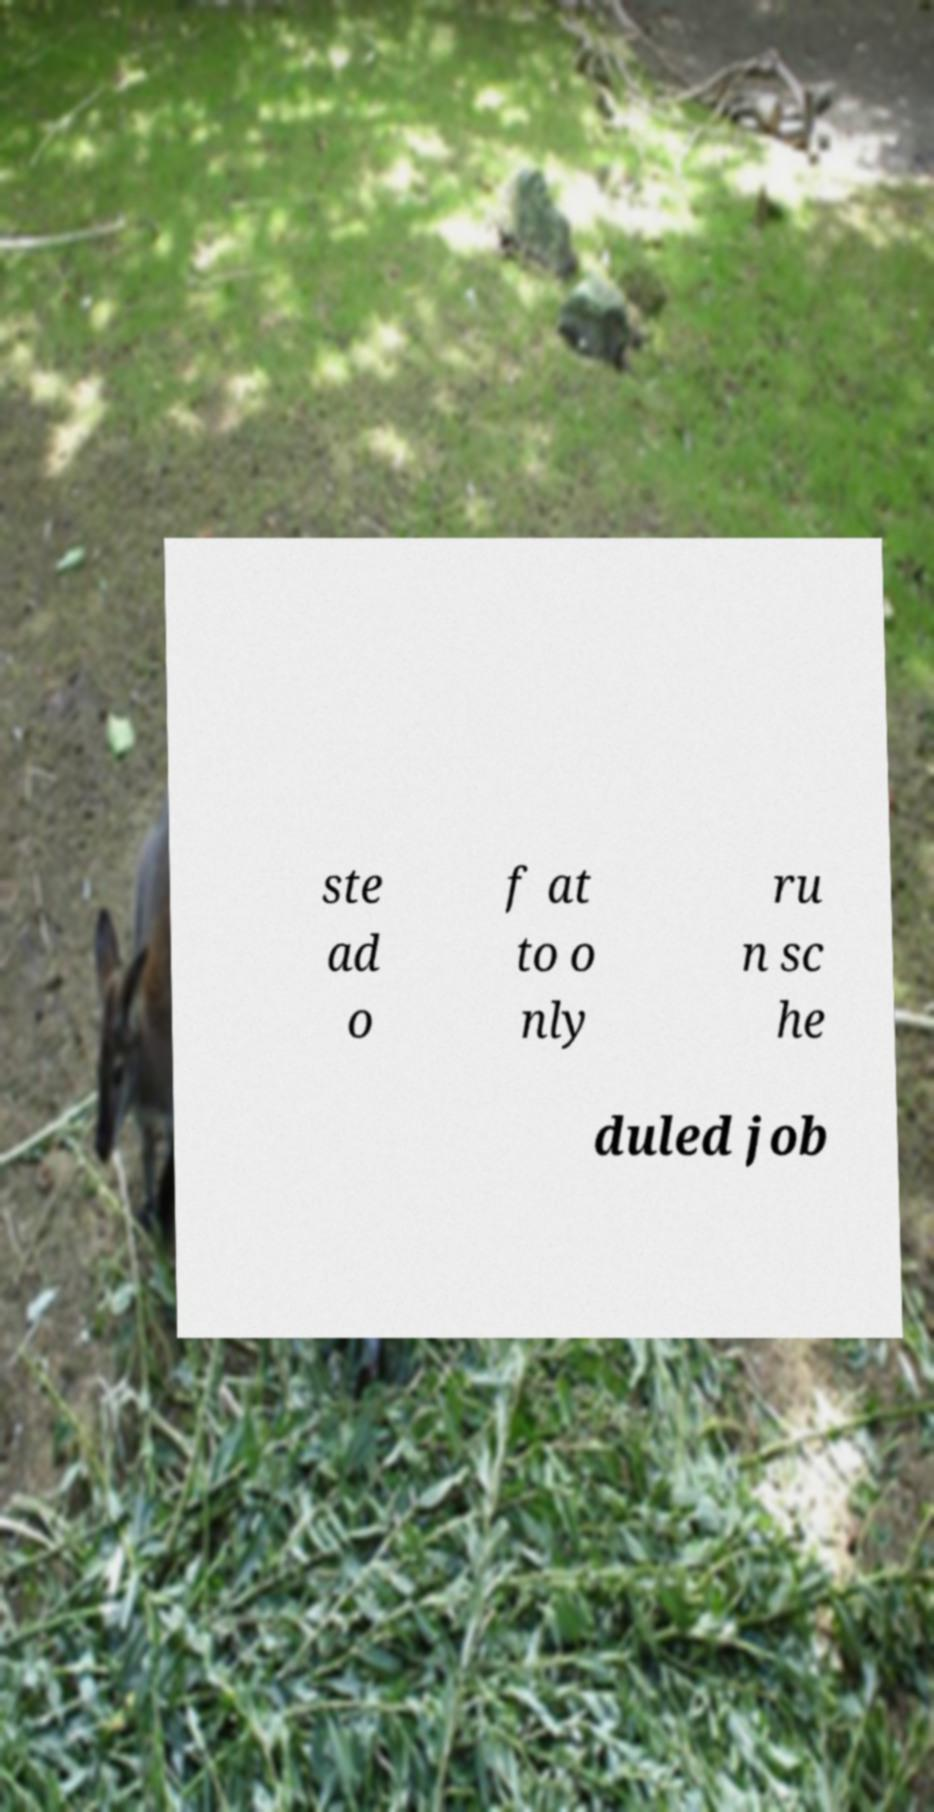Please read and relay the text visible in this image. What does it say? ste ad o f at to o nly ru n sc he duled job 